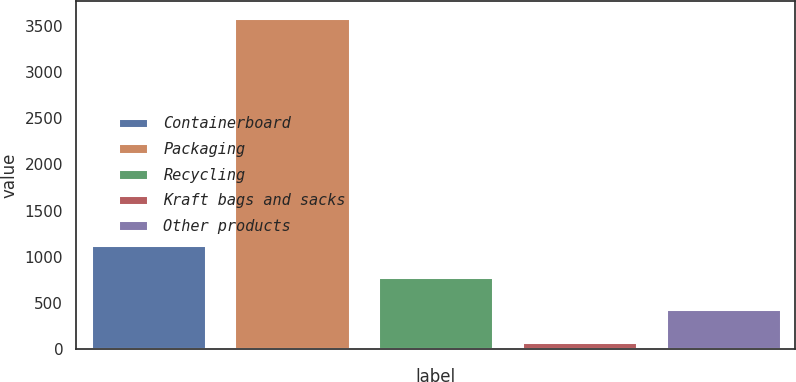<chart> <loc_0><loc_0><loc_500><loc_500><bar_chart><fcel>Containerboard<fcel>Packaging<fcel>Recycling<fcel>Kraft bags and sacks<fcel>Other products<nl><fcel>1131.2<fcel>3584<fcel>780.8<fcel>80<fcel>430.4<nl></chart> 